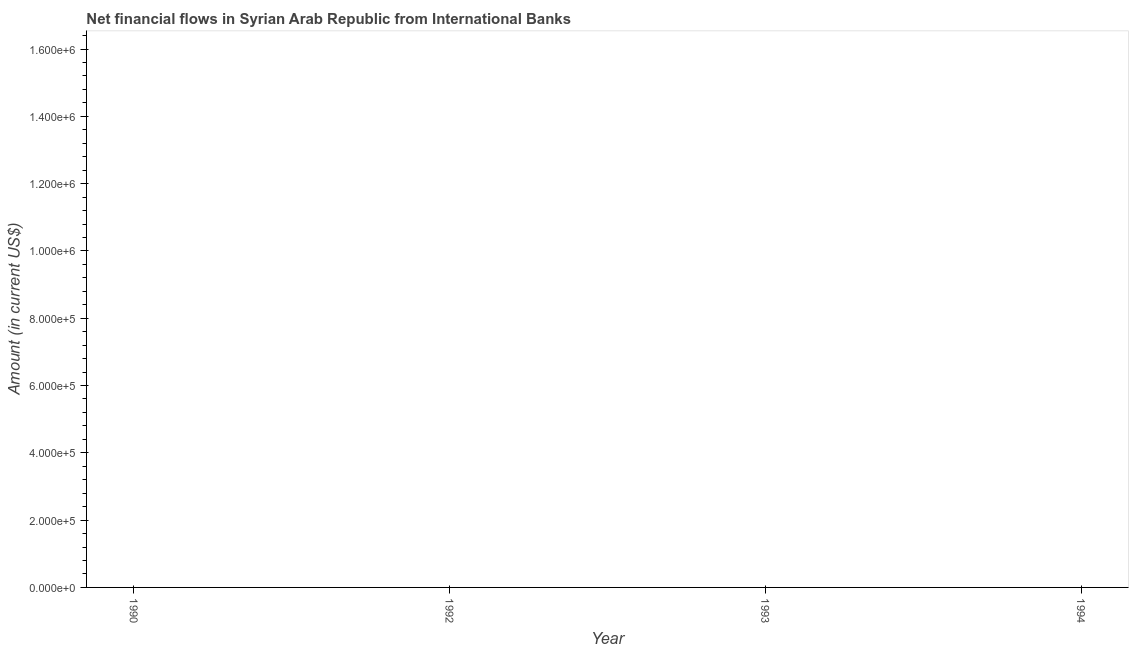What is the sum of the net financial flows from ibrd?
Make the answer very short. 0. What is the average net financial flows from ibrd per year?
Provide a short and direct response. 0. In how many years, is the net financial flows from ibrd greater than 1360000 US$?
Ensure brevity in your answer.  0. In how many years, is the net financial flows from ibrd greater than the average net financial flows from ibrd taken over all years?
Provide a short and direct response. 0. How many lines are there?
Your response must be concise. 0. How many years are there in the graph?
Offer a very short reply. 4. Are the values on the major ticks of Y-axis written in scientific E-notation?
Offer a very short reply. Yes. Does the graph contain any zero values?
Provide a succinct answer. Yes. What is the title of the graph?
Offer a very short reply. Net financial flows in Syrian Arab Republic from International Banks. What is the label or title of the X-axis?
Offer a very short reply. Year. 